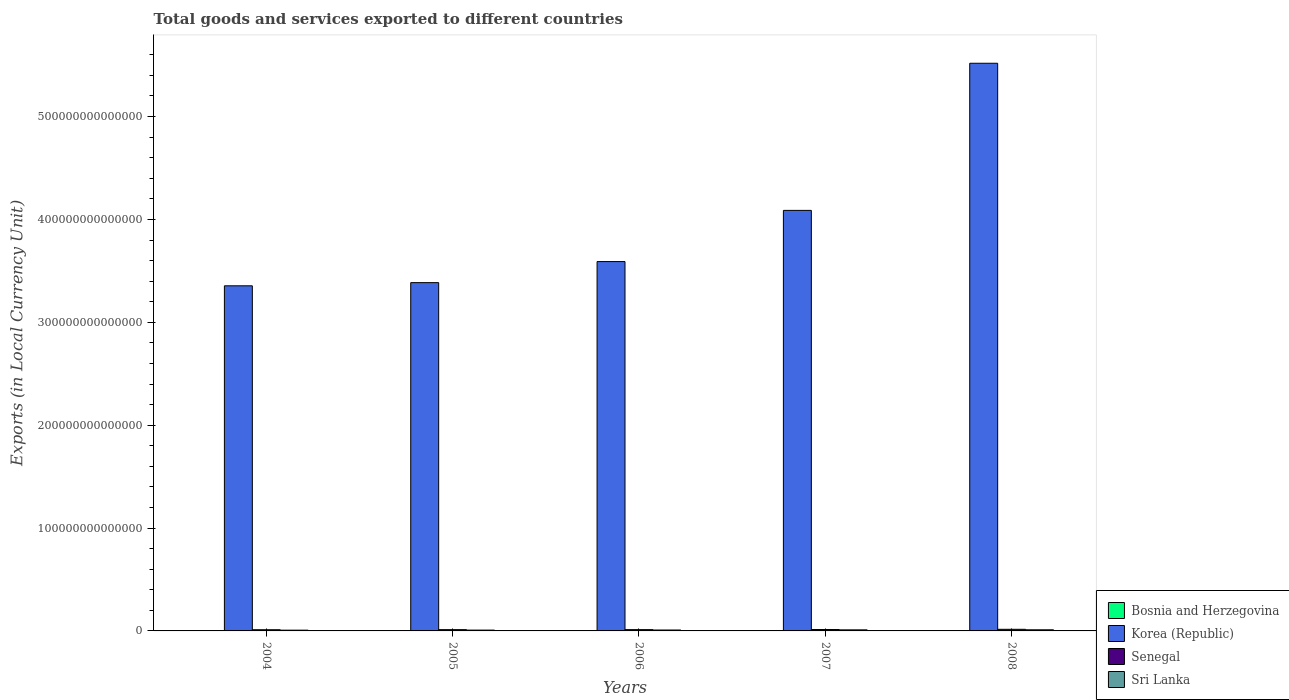How many different coloured bars are there?
Provide a succinct answer. 4. How many groups of bars are there?
Your answer should be compact. 5. Are the number of bars per tick equal to the number of legend labels?
Your response must be concise. Yes. How many bars are there on the 4th tick from the left?
Give a very brief answer. 4. How many bars are there on the 3rd tick from the right?
Offer a very short reply. 4. What is the Amount of goods and services exports in Sri Lanka in 2006?
Offer a very short reply. 8.85e+11. Across all years, what is the maximum Amount of goods and services exports in Korea (Republic)?
Your response must be concise. 5.52e+14. Across all years, what is the minimum Amount of goods and services exports in Senegal?
Offer a very short reply. 1.15e+12. In which year was the Amount of goods and services exports in Bosnia and Herzegovina maximum?
Give a very brief answer. 2006. In which year was the Amount of goods and services exports in Bosnia and Herzegovina minimum?
Ensure brevity in your answer.  2004. What is the total Amount of goods and services exports in Korea (Republic) in the graph?
Your answer should be compact. 1.99e+15. What is the difference between the Amount of goods and services exports in Bosnia and Herzegovina in 2004 and that in 2008?
Your response must be concise. -1.76e+09. What is the difference between the Amount of goods and services exports in Sri Lanka in 2005 and the Amount of goods and services exports in Senegal in 2004?
Your answer should be compact. -3.58e+11. What is the average Amount of goods and services exports in Bosnia and Herzegovina per year?
Your response must be concise. 6.13e+09. In the year 2004, what is the difference between the Amount of goods and services exports in Sri Lanka and Amount of goods and services exports in Bosnia and Herzegovina?
Provide a succinct answer. 7.34e+11. What is the ratio of the Amount of goods and services exports in Bosnia and Herzegovina in 2004 to that in 2006?
Give a very brief answer. 0.72. Is the difference between the Amount of goods and services exports in Sri Lanka in 2004 and 2008 greater than the difference between the Amount of goods and services exports in Bosnia and Herzegovina in 2004 and 2008?
Your answer should be compact. No. What is the difference between the highest and the second highest Amount of goods and services exports in Sri Lanka?
Make the answer very short. 5.37e+1. What is the difference between the highest and the lowest Amount of goods and services exports in Senegal?
Offer a very short reply. 4.15e+11. What does the 3rd bar from the left in 2004 represents?
Keep it short and to the point. Senegal. What does the 1st bar from the right in 2006 represents?
Provide a succinct answer. Sri Lanka. Is it the case that in every year, the sum of the Amount of goods and services exports in Sri Lanka and Amount of goods and services exports in Bosnia and Herzegovina is greater than the Amount of goods and services exports in Korea (Republic)?
Offer a very short reply. No. How many bars are there?
Provide a short and direct response. 20. How many years are there in the graph?
Keep it short and to the point. 5. What is the difference between two consecutive major ticks on the Y-axis?
Make the answer very short. 1.00e+14. Does the graph contain any zero values?
Give a very brief answer. No. Does the graph contain grids?
Ensure brevity in your answer.  No. How many legend labels are there?
Provide a succinct answer. 4. How are the legend labels stacked?
Your answer should be very brief. Vertical. What is the title of the graph?
Provide a short and direct response. Total goods and services exported to different countries. What is the label or title of the Y-axis?
Provide a succinct answer. Exports (in Local Currency Unit). What is the Exports (in Local Currency Unit) of Bosnia and Herzegovina in 2004?
Offer a very short reply. 5.09e+09. What is the Exports (in Local Currency Unit) in Korea (Republic) in 2004?
Your response must be concise. 3.35e+14. What is the Exports (in Local Currency Unit) in Senegal in 2004?
Give a very brief answer. 1.15e+12. What is the Exports (in Local Currency Unit) in Sri Lanka in 2004?
Provide a short and direct response. 7.39e+11. What is the Exports (in Local Currency Unit) in Bosnia and Herzegovina in 2005?
Your response must be concise. 5.58e+09. What is the Exports (in Local Currency Unit) of Korea (Republic) in 2005?
Your answer should be compact. 3.39e+14. What is the Exports (in Local Currency Unit) in Senegal in 2005?
Offer a very short reply. 1.24e+12. What is the Exports (in Local Currency Unit) of Sri Lanka in 2005?
Your response must be concise. 7.93e+11. What is the Exports (in Local Currency Unit) of Bosnia and Herzegovina in 2006?
Your response must be concise. 7.02e+09. What is the Exports (in Local Currency Unit) in Korea (Republic) in 2006?
Your response must be concise. 3.59e+14. What is the Exports (in Local Currency Unit) in Senegal in 2006?
Provide a succinct answer. 1.25e+12. What is the Exports (in Local Currency Unit) in Sri Lanka in 2006?
Keep it short and to the point. 8.85e+11. What is the Exports (in Local Currency Unit) in Bosnia and Herzegovina in 2007?
Offer a terse response. 6.11e+09. What is the Exports (in Local Currency Unit) of Korea (Republic) in 2007?
Keep it short and to the point. 4.09e+14. What is the Exports (in Local Currency Unit) of Senegal in 2007?
Your answer should be compact. 1.38e+12. What is the Exports (in Local Currency Unit) in Sri Lanka in 2007?
Make the answer very short. 1.04e+12. What is the Exports (in Local Currency Unit) of Bosnia and Herzegovina in 2008?
Offer a terse response. 6.85e+09. What is the Exports (in Local Currency Unit) in Korea (Republic) in 2008?
Give a very brief answer. 5.52e+14. What is the Exports (in Local Currency Unit) of Senegal in 2008?
Provide a succinct answer. 1.57e+12. What is the Exports (in Local Currency Unit) of Sri Lanka in 2008?
Your answer should be compact. 1.10e+12. Across all years, what is the maximum Exports (in Local Currency Unit) of Bosnia and Herzegovina?
Your answer should be very brief. 7.02e+09. Across all years, what is the maximum Exports (in Local Currency Unit) in Korea (Republic)?
Your response must be concise. 5.52e+14. Across all years, what is the maximum Exports (in Local Currency Unit) of Senegal?
Make the answer very short. 1.57e+12. Across all years, what is the maximum Exports (in Local Currency Unit) in Sri Lanka?
Your response must be concise. 1.10e+12. Across all years, what is the minimum Exports (in Local Currency Unit) in Bosnia and Herzegovina?
Make the answer very short. 5.09e+09. Across all years, what is the minimum Exports (in Local Currency Unit) in Korea (Republic)?
Keep it short and to the point. 3.35e+14. Across all years, what is the minimum Exports (in Local Currency Unit) of Senegal?
Your response must be concise. 1.15e+12. Across all years, what is the minimum Exports (in Local Currency Unit) of Sri Lanka?
Provide a succinct answer. 7.39e+11. What is the total Exports (in Local Currency Unit) of Bosnia and Herzegovina in the graph?
Offer a terse response. 3.07e+1. What is the total Exports (in Local Currency Unit) of Korea (Republic) in the graph?
Offer a very short reply. 1.99e+15. What is the total Exports (in Local Currency Unit) of Senegal in the graph?
Give a very brief answer. 6.59e+12. What is the total Exports (in Local Currency Unit) in Sri Lanka in the graph?
Provide a short and direct response. 4.55e+12. What is the difference between the Exports (in Local Currency Unit) in Bosnia and Herzegovina in 2004 and that in 2005?
Offer a terse response. -4.93e+08. What is the difference between the Exports (in Local Currency Unit) in Korea (Republic) in 2004 and that in 2005?
Your answer should be very brief. -3.10e+12. What is the difference between the Exports (in Local Currency Unit) of Senegal in 2004 and that in 2005?
Your answer should be compact. -8.94e+1. What is the difference between the Exports (in Local Currency Unit) of Sri Lanka in 2004 and that in 2005?
Offer a very short reply. -5.44e+1. What is the difference between the Exports (in Local Currency Unit) of Bosnia and Herzegovina in 2004 and that in 2006?
Keep it short and to the point. -1.93e+09. What is the difference between the Exports (in Local Currency Unit) of Korea (Republic) in 2004 and that in 2006?
Make the answer very short. -2.36e+13. What is the difference between the Exports (in Local Currency Unit) in Senegal in 2004 and that in 2006?
Provide a short and direct response. -1.03e+11. What is the difference between the Exports (in Local Currency Unit) in Sri Lanka in 2004 and that in 2006?
Keep it short and to the point. -1.47e+11. What is the difference between the Exports (in Local Currency Unit) of Bosnia and Herzegovina in 2004 and that in 2007?
Offer a terse response. -1.02e+09. What is the difference between the Exports (in Local Currency Unit) in Korea (Republic) in 2004 and that in 2007?
Make the answer very short. -7.33e+13. What is the difference between the Exports (in Local Currency Unit) of Senegal in 2004 and that in 2007?
Ensure brevity in your answer.  -2.25e+11. What is the difference between the Exports (in Local Currency Unit) of Sri Lanka in 2004 and that in 2007?
Your answer should be very brief. -3.03e+11. What is the difference between the Exports (in Local Currency Unit) in Bosnia and Herzegovina in 2004 and that in 2008?
Keep it short and to the point. -1.76e+09. What is the difference between the Exports (in Local Currency Unit) in Korea (Republic) in 2004 and that in 2008?
Your answer should be compact. -2.16e+14. What is the difference between the Exports (in Local Currency Unit) in Senegal in 2004 and that in 2008?
Your response must be concise. -4.15e+11. What is the difference between the Exports (in Local Currency Unit) in Sri Lanka in 2004 and that in 2008?
Ensure brevity in your answer.  -3.57e+11. What is the difference between the Exports (in Local Currency Unit) in Bosnia and Herzegovina in 2005 and that in 2006?
Make the answer very short. -1.44e+09. What is the difference between the Exports (in Local Currency Unit) of Korea (Republic) in 2005 and that in 2006?
Provide a short and direct response. -2.05e+13. What is the difference between the Exports (in Local Currency Unit) of Senegal in 2005 and that in 2006?
Give a very brief answer. -1.32e+1. What is the difference between the Exports (in Local Currency Unit) in Sri Lanka in 2005 and that in 2006?
Give a very brief answer. -9.22e+1. What is the difference between the Exports (in Local Currency Unit) of Bosnia and Herzegovina in 2005 and that in 2007?
Your response must be concise. -5.28e+08. What is the difference between the Exports (in Local Currency Unit) in Korea (Republic) in 2005 and that in 2007?
Ensure brevity in your answer.  -7.02e+13. What is the difference between the Exports (in Local Currency Unit) in Senegal in 2005 and that in 2007?
Your answer should be very brief. -1.35e+11. What is the difference between the Exports (in Local Currency Unit) of Sri Lanka in 2005 and that in 2007?
Your answer should be compact. -2.49e+11. What is the difference between the Exports (in Local Currency Unit) in Bosnia and Herzegovina in 2005 and that in 2008?
Offer a terse response. -1.27e+09. What is the difference between the Exports (in Local Currency Unit) in Korea (Republic) in 2005 and that in 2008?
Offer a very short reply. -2.13e+14. What is the difference between the Exports (in Local Currency Unit) in Senegal in 2005 and that in 2008?
Your answer should be very brief. -3.25e+11. What is the difference between the Exports (in Local Currency Unit) of Sri Lanka in 2005 and that in 2008?
Give a very brief answer. -3.03e+11. What is the difference between the Exports (in Local Currency Unit) of Bosnia and Herzegovina in 2006 and that in 2007?
Provide a short and direct response. 9.14e+08. What is the difference between the Exports (in Local Currency Unit) of Korea (Republic) in 2006 and that in 2007?
Make the answer very short. -4.98e+13. What is the difference between the Exports (in Local Currency Unit) in Senegal in 2006 and that in 2007?
Your answer should be very brief. -1.22e+11. What is the difference between the Exports (in Local Currency Unit) in Sri Lanka in 2006 and that in 2007?
Keep it short and to the point. -1.57e+11. What is the difference between the Exports (in Local Currency Unit) of Bosnia and Herzegovina in 2006 and that in 2008?
Keep it short and to the point. 1.73e+08. What is the difference between the Exports (in Local Currency Unit) in Korea (Republic) in 2006 and that in 2008?
Provide a succinct answer. -1.93e+14. What is the difference between the Exports (in Local Currency Unit) in Senegal in 2006 and that in 2008?
Keep it short and to the point. -3.12e+11. What is the difference between the Exports (in Local Currency Unit) in Sri Lanka in 2006 and that in 2008?
Provide a succinct answer. -2.10e+11. What is the difference between the Exports (in Local Currency Unit) of Bosnia and Herzegovina in 2007 and that in 2008?
Your answer should be very brief. -7.41e+08. What is the difference between the Exports (in Local Currency Unit) in Korea (Republic) in 2007 and that in 2008?
Your answer should be very brief. -1.43e+14. What is the difference between the Exports (in Local Currency Unit) in Senegal in 2007 and that in 2008?
Make the answer very short. -1.90e+11. What is the difference between the Exports (in Local Currency Unit) of Sri Lanka in 2007 and that in 2008?
Provide a succinct answer. -5.37e+1. What is the difference between the Exports (in Local Currency Unit) in Bosnia and Herzegovina in 2004 and the Exports (in Local Currency Unit) in Korea (Republic) in 2005?
Make the answer very short. -3.39e+14. What is the difference between the Exports (in Local Currency Unit) in Bosnia and Herzegovina in 2004 and the Exports (in Local Currency Unit) in Senegal in 2005?
Give a very brief answer. -1.24e+12. What is the difference between the Exports (in Local Currency Unit) in Bosnia and Herzegovina in 2004 and the Exports (in Local Currency Unit) in Sri Lanka in 2005?
Give a very brief answer. -7.88e+11. What is the difference between the Exports (in Local Currency Unit) in Korea (Republic) in 2004 and the Exports (in Local Currency Unit) in Senegal in 2005?
Provide a short and direct response. 3.34e+14. What is the difference between the Exports (in Local Currency Unit) in Korea (Republic) in 2004 and the Exports (in Local Currency Unit) in Sri Lanka in 2005?
Your answer should be very brief. 3.35e+14. What is the difference between the Exports (in Local Currency Unit) of Senegal in 2004 and the Exports (in Local Currency Unit) of Sri Lanka in 2005?
Your response must be concise. 3.58e+11. What is the difference between the Exports (in Local Currency Unit) in Bosnia and Herzegovina in 2004 and the Exports (in Local Currency Unit) in Korea (Republic) in 2006?
Give a very brief answer. -3.59e+14. What is the difference between the Exports (in Local Currency Unit) in Bosnia and Herzegovina in 2004 and the Exports (in Local Currency Unit) in Senegal in 2006?
Keep it short and to the point. -1.25e+12. What is the difference between the Exports (in Local Currency Unit) in Bosnia and Herzegovina in 2004 and the Exports (in Local Currency Unit) in Sri Lanka in 2006?
Provide a short and direct response. -8.80e+11. What is the difference between the Exports (in Local Currency Unit) in Korea (Republic) in 2004 and the Exports (in Local Currency Unit) in Senegal in 2006?
Offer a very short reply. 3.34e+14. What is the difference between the Exports (in Local Currency Unit) in Korea (Republic) in 2004 and the Exports (in Local Currency Unit) in Sri Lanka in 2006?
Keep it short and to the point. 3.35e+14. What is the difference between the Exports (in Local Currency Unit) of Senegal in 2004 and the Exports (in Local Currency Unit) of Sri Lanka in 2006?
Your answer should be very brief. 2.66e+11. What is the difference between the Exports (in Local Currency Unit) in Bosnia and Herzegovina in 2004 and the Exports (in Local Currency Unit) in Korea (Republic) in 2007?
Your answer should be compact. -4.09e+14. What is the difference between the Exports (in Local Currency Unit) of Bosnia and Herzegovina in 2004 and the Exports (in Local Currency Unit) of Senegal in 2007?
Keep it short and to the point. -1.37e+12. What is the difference between the Exports (in Local Currency Unit) of Bosnia and Herzegovina in 2004 and the Exports (in Local Currency Unit) of Sri Lanka in 2007?
Your answer should be very brief. -1.04e+12. What is the difference between the Exports (in Local Currency Unit) in Korea (Republic) in 2004 and the Exports (in Local Currency Unit) in Senegal in 2007?
Your answer should be compact. 3.34e+14. What is the difference between the Exports (in Local Currency Unit) in Korea (Republic) in 2004 and the Exports (in Local Currency Unit) in Sri Lanka in 2007?
Ensure brevity in your answer.  3.34e+14. What is the difference between the Exports (in Local Currency Unit) of Senegal in 2004 and the Exports (in Local Currency Unit) of Sri Lanka in 2007?
Your answer should be very brief. 1.10e+11. What is the difference between the Exports (in Local Currency Unit) of Bosnia and Herzegovina in 2004 and the Exports (in Local Currency Unit) of Korea (Republic) in 2008?
Your response must be concise. -5.52e+14. What is the difference between the Exports (in Local Currency Unit) in Bosnia and Herzegovina in 2004 and the Exports (in Local Currency Unit) in Senegal in 2008?
Your answer should be compact. -1.56e+12. What is the difference between the Exports (in Local Currency Unit) of Bosnia and Herzegovina in 2004 and the Exports (in Local Currency Unit) of Sri Lanka in 2008?
Keep it short and to the point. -1.09e+12. What is the difference between the Exports (in Local Currency Unit) in Korea (Republic) in 2004 and the Exports (in Local Currency Unit) in Senegal in 2008?
Provide a short and direct response. 3.34e+14. What is the difference between the Exports (in Local Currency Unit) of Korea (Republic) in 2004 and the Exports (in Local Currency Unit) of Sri Lanka in 2008?
Your answer should be very brief. 3.34e+14. What is the difference between the Exports (in Local Currency Unit) in Senegal in 2004 and the Exports (in Local Currency Unit) in Sri Lanka in 2008?
Offer a very short reply. 5.58e+1. What is the difference between the Exports (in Local Currency Unit) in Bosnia and Herzegovina in 2005 and the Exports (in Local Currency Unit) in Korea (Republic) in 2006?
Make the answer very short. -3.59e+14. What is the difference between the Exports (in Local Currency Unit) in Bosnia and Herzegovina in 2005 and the Exports (in Local Currency Unit) in Senegal in 2006?
Ensure brevity in your answer.  -1.25e+12. What is the difference between the Exports (in Local Currency Unit) of Bosnia and Herzegovina in 2005 and the Exports (in Local Currency Unit) of Sri Lanka in 2006?
Your answer should be very brief. -8.80e+11. What is the difference between the Exports (in Local Currency Unit) in Korea (Republic) in 2005 and the Exports (in Local Currency Unit) in Senegal in 2006?
Keep it short and to the point. 3.37e+14. What is the difference between the Exports (in Local Currency Unit) of Korea (Republic) in 2005 and the Exports (in Local Currency Unit) of Sri Lanka in 2006?
Your response must be concise. 3.38e+14. What is the difference between the Exports (in Local Currency Unit) in Senegal in 2005 and the Exports (in Local Currency Unit) in Sri Lanka in 2006?
Your response must be concise. 3.55e+11. What is the difference between the Exports (in Local Currency Unit) in Bosnia and Herzegovina in 2005 and the Exports (in Local Currency Unit) in Korea (Republic) in 2007?
Ensure brevity in your answer.  -4.09e+14. What is the difference between the Exports (in Local Currency Unit) of Bosnia and Herzegovina in 2005 and the Exports (in Local Currency Unit) of Senegal in 2007?
Your answer should be very brief. -1.37e+12. What is the difference between the Exports (in Local Currency Unit) in Bosnia and Herzegovina in 2005 and the Exports (in Local Currency Unit) in Sri Lanka in 2007?
Your answer should be very brief. -1.04e+12. What is the difference between the Exports (in Local Currency Unit) of Korea (Republic) in 2005 and the Exports (in Local Currency Unit) of Senegal in 2007?
Give a very brief answer. 3.37e+14. What is the difference between the Exports (in Local Currency Unit) in Korea (Republic) in 2005 and the Exports (in Local Currency Unit) in Sri Lanka in 2007?
Your answer should be very brief. 3.38e+14. What is the difference between the Exports (in Local Currency Unit) of Senegal in 2005 and the Exports (in Local Currency Unit) of Sri Lanka in 2007?
Provide a succinct answer. 1.99e+11. What is the difference between the Exports (in Local Currency Unit) in Bosnia and Herzegovina in 2005 and the Exports (in Local Currency Unit) in Korea (Republic) in 2008?
Your answer should be very brief. -5.52e+14. What is the difference between the Exports (in Local Currency Unit) of Bosnia and Herzegovina in 2005 and the Exports (in Local Currency Unit) of Senegal in 2008?
Your answer should be compact. -1.56e+12. What is the difference between the Exports (in Local Currency Unit) of Bosnia and Herzegovina in 2005 and the Exports (in Local Currency Unit) of Sri Lanka in 2008?
Keep it short and to the point. -1.09e+12. What is the difference between the Exports (in Local Currency Unit) of Korea (Republic) in 2005 and the Exports (in Local Currency Unit) of Senegal in 2008?
Your response must be concise. 3.37e+14. What is the difference between the Exports (in Local Currency Unit) in Korea (Republic) in 2005 and the Exports (in Local Currency Unit) in Sri Lanka in 2008?
Make the answer very short. 3.37e+14. What is the difference between the Exports (in Local Currency Unit) in Senegal in 2005 and the Exports (in Local Currency Unit) in Sri Lanka in 2008?
Offer a very short reply. 1.45e+11. What is the difference between the Exports (in Local Currency Unit) in Bosnia and Herzegovina in 2006 and the Exports (in Local Currency Unit) in Korea (Republic) in 2007?
Your response must be concise. -4.09e+14. What is the difference between the Exports (in Local Currency Unit) of Bosnia and Herzegovina in 2006 and the Exports (in Local Currency Unit) of Senegal in 2007?
Your answer should be compact. -1.37e+12. What is the difference between the Exports (in Local Currency Unit) in Bosnia and Herzegovina in 2006 and the Exports (in Local Currency Unit) in Sri Lanka in 2007?
Make the answer very short. -1.03e+12. What is the difference between the Exports (in Local Currency Unit) in Korea (Republic) in 2006 and the Exports (in Local Currency Unit) in Senegal in 2007?
Ensure brevity in your answer.  3.58e+14. What is the difference between the Exports (in Local Currency Unit) of Korea (Republic) in 2006 and the Exports (in Local Currency Unit) of Sri Lanka in 2007?
Your answer should be very brief. 3.58e+14. What is the difference between the Exports (in Local Currency Unit) of Senegal in 2006 and the Exports (in Local Currency Unit) of Sri Lanka in 2007?
Your answer should be compact. 2.12e+11. What is the difference between the Exports (in Local Currency Unit) in Bosnia and Herzegovina in 2006 and the Exports (in Local Currency Unit) in Korea (Republic) in 2008?
Make the answer very short. -5.52e+14. What is the difference between the Exports (in Local Currency Unit) in Bosnia and Herzegovina in 2006 and the Exports (in Local Currency Unit) in Senegal in 2008?
Keep it short and to the point. -1.56e+12. What is the difference between the Exports (in Local Currency Unit) in Bosnia and Herzegovina in 2006 and the Exports (in Local Currency Unit) in Sri Lanka in 2008?
Offer a terse response. -1.09e+12. What is the difference between the Exports (in Local Currency Unit) of Korea (Republic) in 2006 and the Exports (in Local Currency Unit) of Senegal in 2008?
Provide a short and direct response. 3.57e+14. What is the difference between the Exports (in Local Currency Unit) of Korea (Republic) in 2006 and the Exports (in Local Currency Unit) of Sri Lanka in 2008?
Your answer should be very brief. 3.58e+14. What is the difference between the Exports (in Local Currency Unit) of Senegal in 2006 and the Exports (in Local Currency Unit) of Sri Lanka in 2008?
Provide a succinct answer. 1.58e+11. What is the difference between the Exports (in Local Currency Unit) of Bosnia and Herzegovina in 2007 and the Exports (in Local Currency Unit) of Korea (Republic) in 2008?
Make the answer very short. -5.52e+14. What is the difference between the Exports (in Local Currency Unit) of Bosnia and Herzegovina in 2007 and the Exports (in Local Currency Unit) of Senegal in 2008?
Ensure brevity in your answer.  -1.56e+12. What is the difference between the Exports (in Local Currency Unit) in Bosnia and Herzegovina in 2007 and the Exports (in Local Currency Unit) in Sri Lanka in 2008?
Your answer should be compact. -1.09e+12. What is the difference between the Exports (in Local Currency Unit) of Korea (Republic) in 2007 and the Exports (in Local Currency Unit) of Senegal in 2008?
Your answer should be very brief. 4.07e+14. What is the difference between the Exports (in Local Currency Unit) in Korea (Republic) in 2007 and the Exports (in Local Currency Unit) in Sri Lanka in 2008?
Provide a short and direct response. 4.08e+14. What is the difference between the Exports (in Local Currency Unit) in Senegal in 2007 and the Exports (in Local Currency Unit) in Sri Lanka in 2008?
Offer a very short reply. 2.81e+11. What is the average Exports (in Local Currency Unit) of Bosnia and Herzegovina per year?
Provide a short and direct response. 6.13e+09. What is the average Exports (in Local Currency Unit) in Korea (Republic) per year?
Offer a very short reply. 3.99e+14. What is the average Exports (in Local Currency Unit) of Senegal per year?
Provide a short and direct response. 1.32e+12. What is the average Exports (in Local Currency Unit) in Sri Lanka per year?
Your response must be concise. 9.11e+11. In the year 2004, what is the difference between the Exports (in Local Currency Unit) of Bosnia and Herzegovina and Exports (in Local Currency Unit) of Korea (Republic)?
Your answer should be compact. -3.35e+14. In the year 2004, what is the difference between the Exports (in Local Currency Unit) in Bosnia and Herzegovina and Exports (in Local Currency Unit) in Senegal?
Your answer should be very brief. -1.15e+12. In the year 2004, what is the difference between the Exports (in Local Currency Unit) of Bosnia and Herzegovina and Exports (in Local Currency Unit) of Sri Lanka?
Your response must be concise. -7.34e+11. In the year 2004, what is the difference between the Exports (in Local Currency Unit) in Korea (Republic) and Exports (in Local Currency Unit) in Senegal?
Keep it short and to the point. 3.34e+14. In the year 2004, what is the difference between the Exports (in Local Currency Unit) in Korea (Republic) and Exports (in Local Currency Unit) in Sri Lanka?
Your answer should be very brief. 3.35e+14. In the year 2004, what is the difference between the Exports (in Local Currency Unit) in Senegal and Exports (in Local Currency Unit) in Sri Lanka?
Your answer should be compact. 4.13e+11. In the year 2005, what is the difference between the Exports (in Local Currency Unit) of Bosnia and Herzegovina and Exports (in Local Currency Unit) of Korea (Republic)?
Provide a succinct answer. -3.39e+14. In the year 2005, what is the difference between the Exports (in Local Currency Unit) of Bosnia and Herzegovina and Exports (in Local Currency Unit) of Senegal?
Keep it short and to the point. -1.24e+12. In the year 2005, what is the difference between the Exports (in Local Currency Unit) in Bosnia and Herzegovina and Exports (in Local Currency Unit) in Sri Lanka?
Your answer should be compact. -7.88e+11. In the year 2005, what is the difference between the Exports (in Local Currency Unit) in Korea (Republic) and Exports (in Local Currency Unit) in Senegal?
Your answer should be compact. 3.37e+14. In the year 2005, what is the difference between the Exports (in Local Currency Unit) in Korea (Republic) and Exports (in Local Currency Unit) in Sri Lanka?
Provide a short and direct response. 3.38e+14. In the year 2005, what is the difference between the Exports (in Local Currency Unit) in Senegal and Exports (in Local Currency Unit) in Sri Lanka?
Provide a short and direct response. 4.48e+11. In the year 2006, what is the difference between the Exports (in Local Currency Unit) of Bosnia and Herzegovina and Exports (in Local Currency Unit) of Korea (Republic)?
Your response must be concise. -3.59e+14. In the year 2006, what is the difference between the Exports (in Local Currency Unit) of Bosnia and Herzegovina and Exports (in Local Currency Unit) of Senegal?
Provide a succinct answer. -1.25e+12. In the year 2006, what is the difference between the Exports (in Local Currency Unit) of Bosnia and Herzegovina and Exports (in Local Currency Unit) of Sri Lanka?
Provide a short and direct response. -8.78e+11. In the year 2006, what is the difference between the Exports (in Local Currency Unit) of Korea (Republic) and Exports (in Local Currency Unit) of Senegal?
Ensure brevity in your answer.  3.58e+14. In the year 2006, what is the difference between the Exports (in Local Currency Unit) of Korea (Republic) and Exports (in Local Currency Unit) of Sri Lanka?
Ensure brevity in your answer.  3.58e+14. In the year 2006, what is the difference between the Exports (in Local Currency Unit) in Senegal and Exports (in Local Currency Unit) in Sri Lanka?
Your answer should be compact. 3.69e+11. In the year 2007, what is the difference between the Exports (in Local Currency Unit) in Bosnia and Herzegovina and Exports (in Local Currency Unit) in Korea (Republic)?
Make the answer very short. -4.09e+14. In the year 2007, what is the difference between the Exports (in Local Currency Unit) in Bosnia and Herzegovina and Exports (in Local Currency Unit) in Senegal?
Keep it short and to the point. -1.37e+12. In the year 2007, what is the difference between the Exports (in Local Currency Unit) in Bosnia and Herzegovina and Exports (in Local Currency Unit) in Sri Lanka?
Offer a very short reply. -1.04e+12. In the year 2007, what is the difference between the Exports (in Local Currency Unit) of Korea (Republic) and Exports (in Local Currency Unit) of Senegal?
Make the answer very short. 4.07e+14. In the year 2007, what is the difference between the Exports (in Local Currency Unit) of Korea (Republic) and Exports (in Local Currency Unit) of Sri Lanka?
Your response must be concise. 4.08e+14. In the year 2007, what is the difference between the Exports (in Local Currency Unit) in Senegal and Exports (in Local Currency Unit) in Sri Lanka?
Keep it short and to the point. 3.34e+11. In the year 2008, what is the difference between the Exports (in Local Currency Unit) in Bosnia and Herzegovina and Exports (in Local Currency Unit) in Korea (Republic)?
Ensure brevity in your answer.  -5.52e+14. In the year 2008, what is the difference between the Exports (in Local Currency Unit) in Bosnia and Herzegovina and Exports (in Local Currency Unit) in Senegal?
Your response must be concise. -1.56e+12. In the year 2008, what is the difference between the Exports (in Local Currency Unit) of Bosnia and Herzegovina and Exports (in Local Currency Unit) of Sri Lanka?
Provide a short and direct response. -1.09e+12. In the year 2008, what is the difference between the Exports (in Local Currency Unit) in Korea (Republic) and Exports (in Local Currency Unit) in Senegal?
Offer a terse response. 5.50e+14. In the year 2008, what is the difference between the Exports (in Local Currency Unit) of Korea (Republic) and Exports (in Local Currency Unit) of Sri Lanka?
Offer a terse response. 5.51e+14. In the year 2008, what is the difference between the Exports (in Local Currency Unit) in Senegal and Exports (in Local Currency Unit) in Sri Lanka?
Give a very brief answer. 4.71e+11. What is the ratio of the Exports (in Local Currency Unit) in Bosnia and Herzegovina in 2004 to that in 2005?
Make the answer very short. 0.91. What is the ratio of the Exports (in Local Currency Unit) in Korea (Republic) in 2004 to that in 2005?
Give a very brief answer. 0.99. What is the ratio of the Exports (in Local Currency Unit) of Senegal in 2004 to that in 2005?
Provide a succinct answer. 0.93. What is the ratio of the Exports (in Local Currency Unit) of Sri Lanka in 2004 to that in 2005?
Offer a terse response. 0.93. What is the ratio of the Exports (in Local Currency Unit) in Bosnia and Herzegovina in 2004 to that in 2006?
Offer a terse response. 0.72. What is the ratio of the Exports (in Local Currency Unit) in Korea (Republic) in 2004 to that in 2006?
Ensure brevity in your answer.  0.93. What is the ratio of the Exports (in Local Currency Unit) in Senegal in 2004 to that in 2006?
Make the answer very short. 0.92. What is the ratio of the Exports (in Local Currency Unit) in Sri Lanka in 2004 to that in 2006?
Ensure brevity in your answer.  0.83. What is the ratio of the Exports (in Local Currency Unit) of Bosnia and Herzegovina in 2004 to that in 2007?
Offer a very short reply. 0.83. What is the ratio of the Exports (in Local Currency Unit) of Korea (Republic) in 2004 to that in 2007?
Make the answer very short. 0.82. What is the ratio of the Exports (in Local Currency Unit) of Senegal in 2004 to that in 2007?
Offer a terse response. 0.84. What is the ratio of the Exports (in Local Currency Unit) of Sri Lanka in 2004 to that in 2007?
Offer a terse response. 0.71. What is the ratio of the Exports (in Local Currency Unit) in Bosnia and Herzegovina in 2004 to that in 2008?
Make the answer very short. 0.74. What is the ratio of the Exports (in Local Currency Unit) in Korea (Republic) in 2004 to that in 2008?
Keep it short and to the point. 0.61. What is the ratio of the Exports (in Local Currency Unit) of Senegal in 2004 to that in 2008?
Your answer should be very brief. 0.74. What is the ratio of the Exports (in Local Currency Unit) in Sri Lanka in 2004 to that in 2008?
Make the answer very short. 0.67. What is the ratio of the Exports (in Local Currency Unit) of Bosnia and Herzegovina in 2005 to that in 2006?
Your response must be concise. 0.79. What is the ratio of the Exports (in Local Currency Unit) in Korea (Republic) in 2005 to that in 2006?
Your response must be concise. 0.94. What is the ratio of the Exports (in Local Currency Unit) of Sri Lanka in 2005 to that in 2006?
Keep it short and to the point. 0.9. What is the ratio of the Exports (in Local Currency Unit) in Bosnia and Herzegovina in 2005 to that in 2007?
Offer a terse response. 0.91. What is the ratio of the Exports (in Local Currency Unit) of Korea (Republic) in 2005 to that in 2007?
Make the answer very short. 0.83. What is the ratio of the Exports (in Local Currency Unit) of Senegal in 2005 to that in 2007?
Your response must be concise. 0.9. What is the ratio of the Exports (in Local Currency Unit) of Sri Lanka in 2005 to that in 2007?
Provide a succinct answer. 0.76. What is the ratio of the Exports (in Local Currency Unit) of Bosnia and Herzegovina in 2005 to that in 2008?
Keep it short and to the point. 0.81. What is the ratio of the Exports (in Local Currency Unit) in Korea (Republic) in 2005 to that in 2008?
Keep it short and to the point. 0.61. What is the ratio of the Exports (in Local Currency Unit) of Senegal in 2005 to that in 2008?
Your response must be concise. 0.79. What is the ratio of the Exports (in Local Currency Unit) in Sri Lanka in 2005 to that in 2008?
Your answer should be very brief. 0.72. What is the ratio of the Exports (in Local Currency Unit) in Bosnia and Herzegovina in 2006 to that in 2007?
Keep it short and to the point. 1.15. What is the ratio of the Exports (in Local Currency Unit) in Korea (Republic) in 2006 to that in 2007?
Offer a terse response. 0.88. What is the ratio of the Exports (in Local Currency Unit) of Senegal in 2006 to that in 2007?
Keep it short and to the point. 0.91. What is the ratio of the Exports (in Local Currency Unit) of Sri Lanka in 2006 to that in 2007?
Provide a succinct answer. 0.85. What is the ratio of the Exports (in Local Currency Unit) in Bosnia and Herzegovina in 2006 to that in 2008?
Your answer should be very brief. 1.03. What is the ratio of the Exports (in Local Currency Unit) in Korea (Republic) in 2006 to that in 2008?
Make the answer very short. 0.65. What is the ratio of the Exports (in Local Currency Unit) of Senegal in 2006 to that in 2008?
Your response must be concise. 0.8. What is the ratio of the Exports (in Local Currency Unit) of Sri Lanka in 2006 to that in 2008?
Provide a succinct answer. 0.81. What is the ratio of the Exports (in Local Currency Unit) of Bosnia and Herzegovina in 2007 to that in 2008?
Make the answer very short. 0.89. What is the ratio of the Exports (in Local Currency Unit) of Korea (Republic) in 2007 to that in 2008?
Your response must be concise. 0.74. What is the ratio of the Exports (in Local Currency Unit) of Senegal in 2007 to that in 2008?
Offer a very short reply. 0.88. What is the ratio of the Exports (in Local Currency Unit) in Sri Lanka in 2007 to that in 2008?
Your answer should be compact. 0.95. What is the difference between the highest and the second highest Exports (in Local Currency Unit) of Bosnia and Herzegovina?
Offer a very short reply. 1.73e+08. What is the difference between the highest and the second highest Exports (in Local Currency Unit) of Korea (Republic)?
Make the answer very short. 1.43e+14. What is the difference between the highest and the second highest Exports (in Local Currency Unit) in Senegal?
Provide a succinct answer. 1.90e+11. What is the difference between the highest and the second highest Exports (in Local Currency Unit) in Sri Lanka?
Offer a terse response. 5.37e+1. What is the difference between the highest and the lowest Exports (in Local Currency Unit) of Bosnia and Herzegovina?
Your answer should be compact. 1.93e+09. What is the difference between the highest and the lowest Exports (in Local Currency Unit) in Korea (Republic)?
Provide a succinct answer. 2.16e+14. What is the difference between the highest and the lowest Exports (in Local Currency Unit) of Senegal?
Give a very brief answer. 4.15e+11. What is the difference between the highest and the lowest Exports (in Local Currency Unit) in Sri Lanka?
Provide a short and direct response. 3.57e+11. 